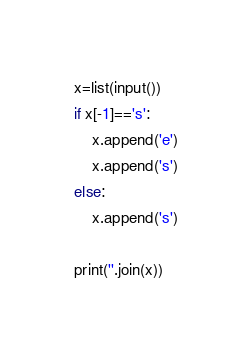Convert code to text. <code><loc_0><loc_0><loc_500><loc_500><_Python_>
x=list(input())
if x[-1]=='s':
    x.append('e')
    x.append('s')
else:
    x.append('s')

print(''.join(x))</code> 